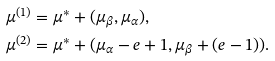<formula> <loc_0><loc_0><loc_500><loc_500>\mu ^ { ( 1 ) } & = \mu ^ { \ast } + ( \mu _ { \beta } , \mu _ { \alpha } ) , \\ \mu ^ { ( 2 ) } & = \mu ^ { \ast } + ( \mu _ { \alpha } - e + 1 , \mu _ { \beta } + ( e - 1 ) ) .</formula> 